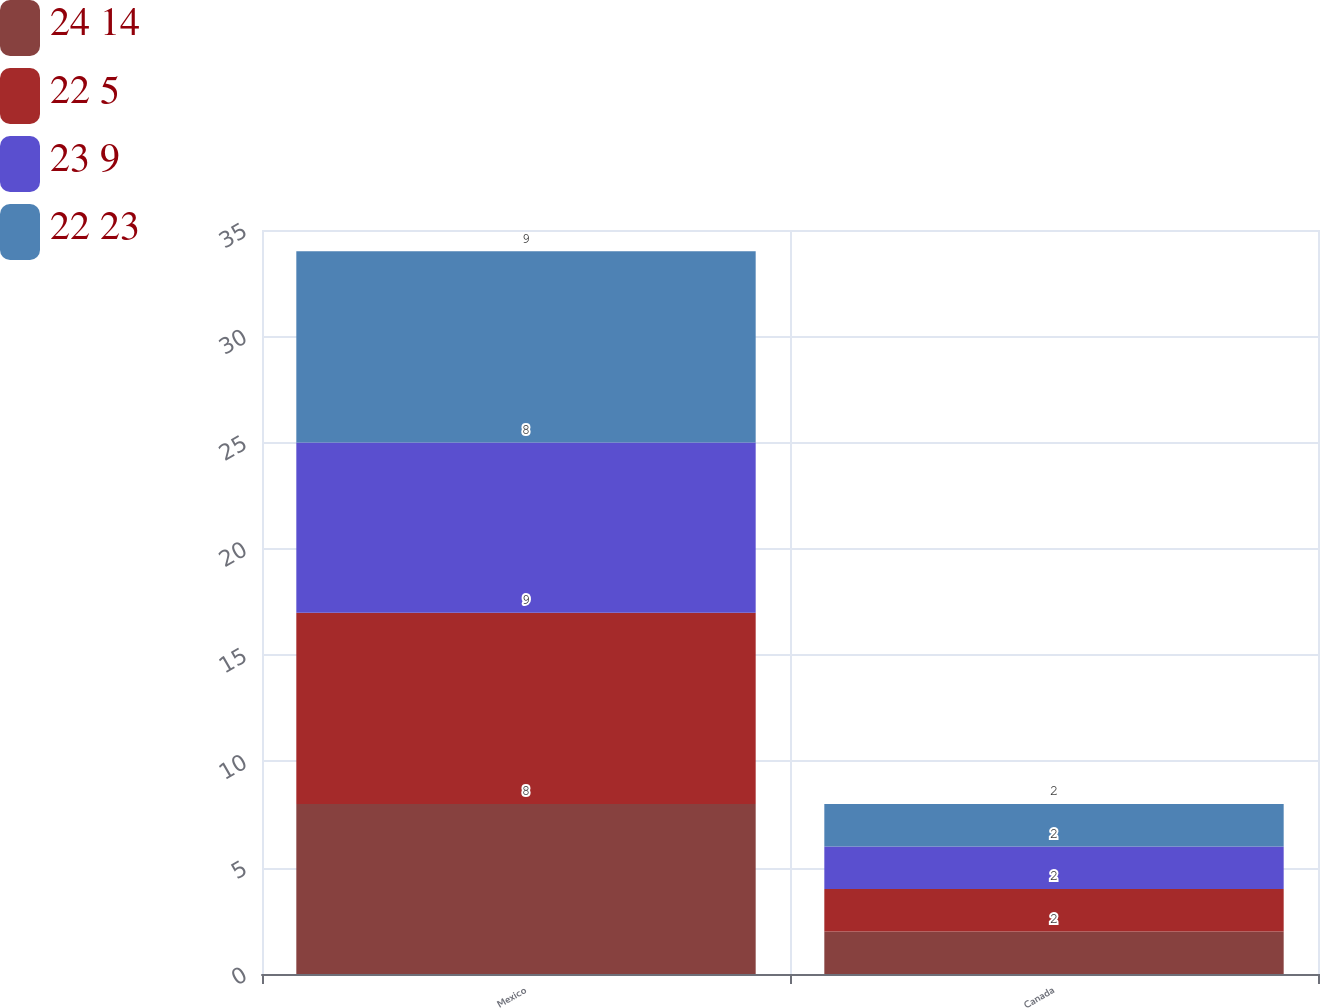Convert chart to OTSL. <chart><loc_0><loc_0><loc_500><loc_500><stacked_bar_chart><ecel><fcel>Mexico<fcel>Canada<nl><fcel>24 14<fcel>8<fcel>2<nl><fcel>22 5<fcel>9<fcel>2<nl><fcel>23 9<fcel>8<fcel>2<nl><fcel>22 23<fcel>9<fcel>2<nl></chart> 